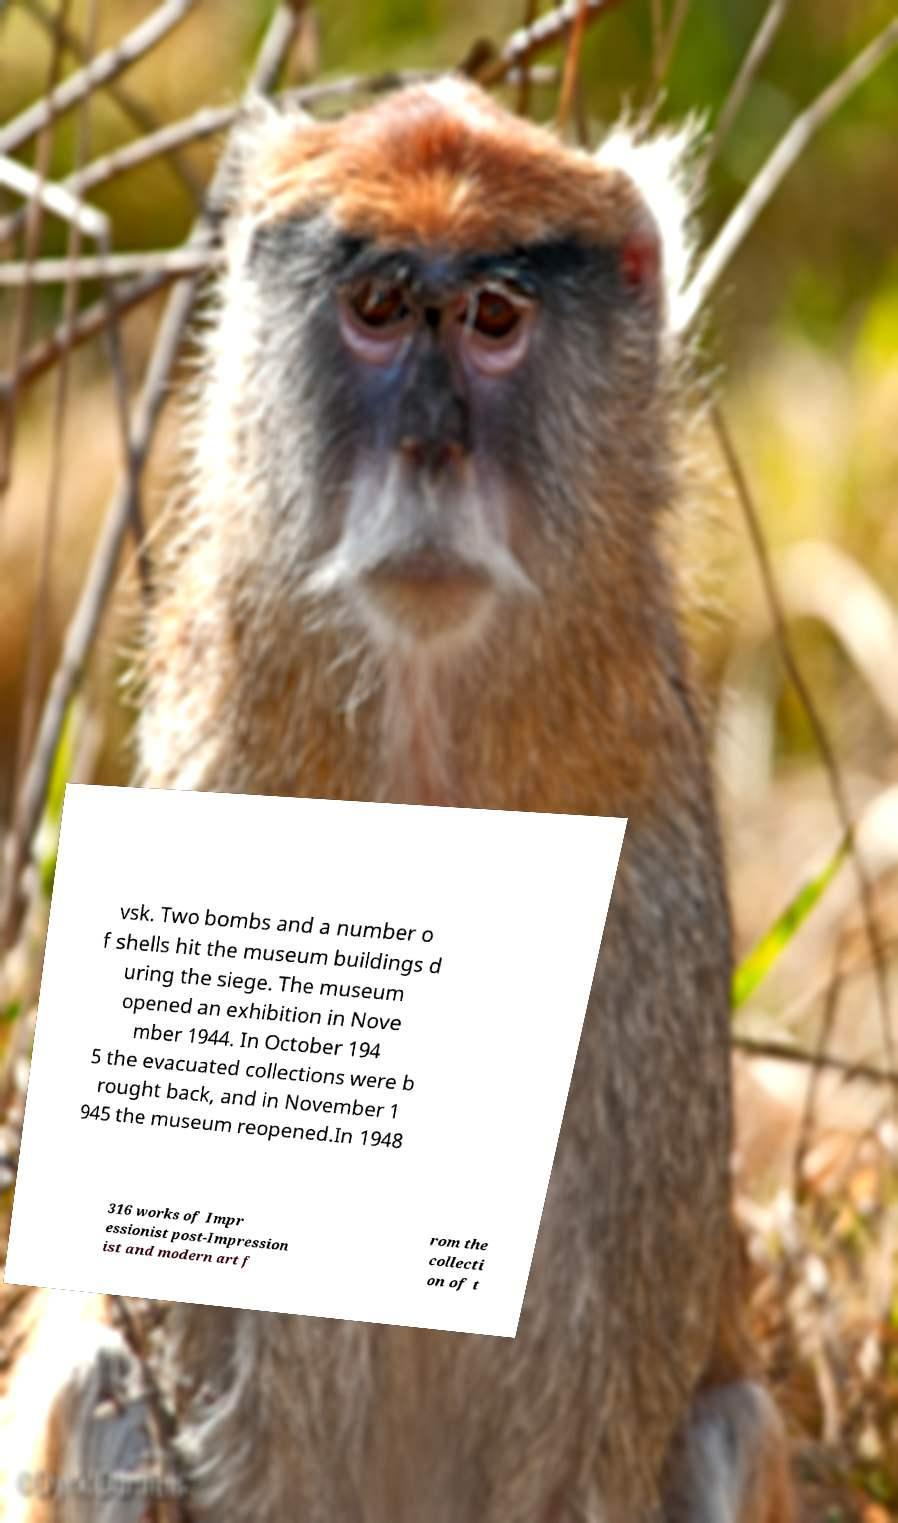Could you assist in decoding the text presented in this image and type it out clearly? vsk. Two bombs and a number o f shells hit the museum buildings d uring the siege. The museum opened an exhibition in Nove mber 1944. In October 194 5 the evacuated collections were b rought back, and in November 1 945 the museum reopened.In 1948 316 works of Impr essionist post-Impression ist and modern art f rom the collecti on of t 